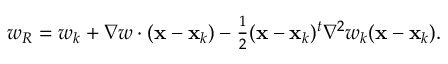<formula> <loc_0><loc_0><loc_500><loc_500>\begin{array} { r } { w _ { R } = w _ { k } + \nabla w \cdot ( { x } - { x } _ { k } ) - \frac { 1 } { 2 } ( { x } - { x } _ { k } ) ^ { t } { \nabla } ^ { 2 } w _ { k } ( { x } - { x } _ { k } ) . } \end{array}</formula> 